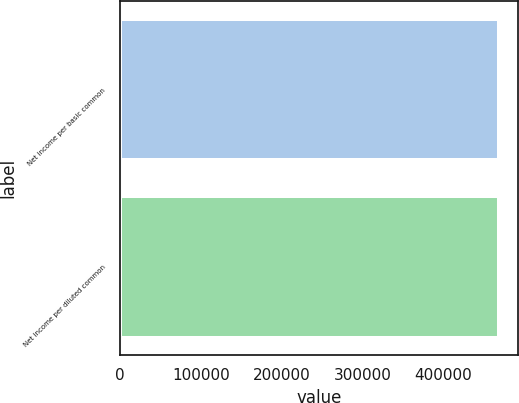Convert chart to OTSL. <chart><loc_0><loc_0><loc_500><loc_500><bar_chart><fcel>Net income per basic common<fcel>Net income per diluted common<nl><fcel>469053<fcel>469053<nl></chart> 